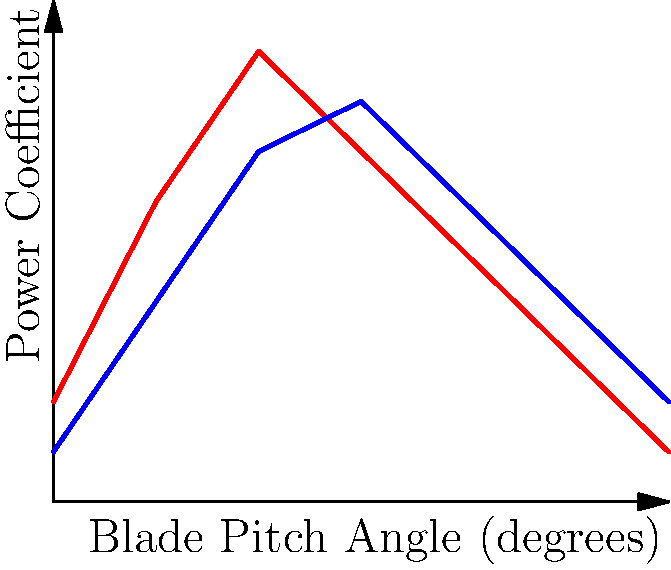As a tech entrepreneur focused on sustainability, you're evaluating different wind turbine blade designs for a new project in Patagonia. The graph shows the power coefficient of two blade designs (A and B) as a function of blade pitch angle. Which design would you choose for maximum energy output in variable wind conditions, and why? To answer this question, we need to analyze the graph and consider the implications for variable wind conditions:

1. Design A (red curve):
   - Reaches a higher peak power coefficient (0.45) at around 30 degrees.
   - Has a narrower range of high efficiency (steeper curve).
   - Performs better at lower pitch angles (0-30 degrees).

2. Design B (blue curve):
   - Has a lower peak power coefficient (0.4) at around 45 degrees.
   - Shows a wider range of high efficiency (flatter curve).
   - Performs better at higher pitch angles (45-90 degrees).

3. Variable wind conditions consideration:
   - In changing wind speeds, the blade pitch angle needs to be adjusted frequently.
   - A design that maintains high efficiency across a wider range of pitch angles is preferable.

4. Efficiency vs. adaptability trade-off:
   - While Design A has a higher peak efficiency, it's more sensitive to pitch angle changes.
   - Design B sacrifices some peak efficiency but maintains good performance over a broader range.

5. Decision:
   - For variable wind conditions, Design B would be the better choice.
   - It offers more consistent energy output across different wind speeds, reducing the need for frequent pitch adjustments.
   - This leads to more stable energy production and potentially lower maintenance costs.

6. Sustainability aspect:
   - Consistent energy production aligns with sustainability goals by maximizing the use of available wind resources.
   - Lower maintenance requirements reduce the overall environmental impact of the turbine over its lifetime.

Therefore, as a tech entrepreneur focused on sustainability, you would choose Design B for its better performance in variable wind conditions, which are common in Patagonia.
Answer: Design B, due to wider efficiency range for variable winds. 